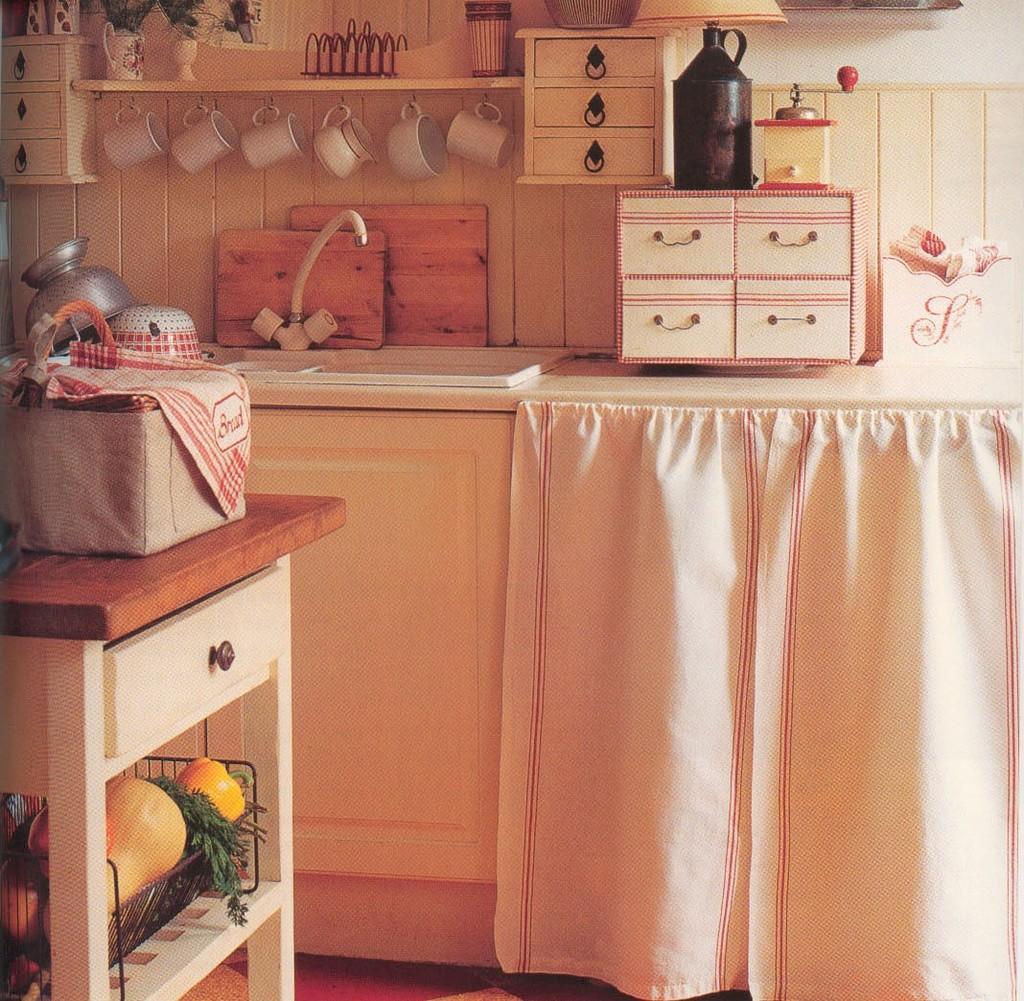How would you summarize this image in a sentence or two? In the picture we can see there are some cups, glasses and house plants. There is a curtain. We can also see there are some racks. In the top right corner of the picture there is a desk and on the desk there is a tin. In the left bottom of the picture we can see a table and under the table there are vegetables and on the table there are some utensils. 